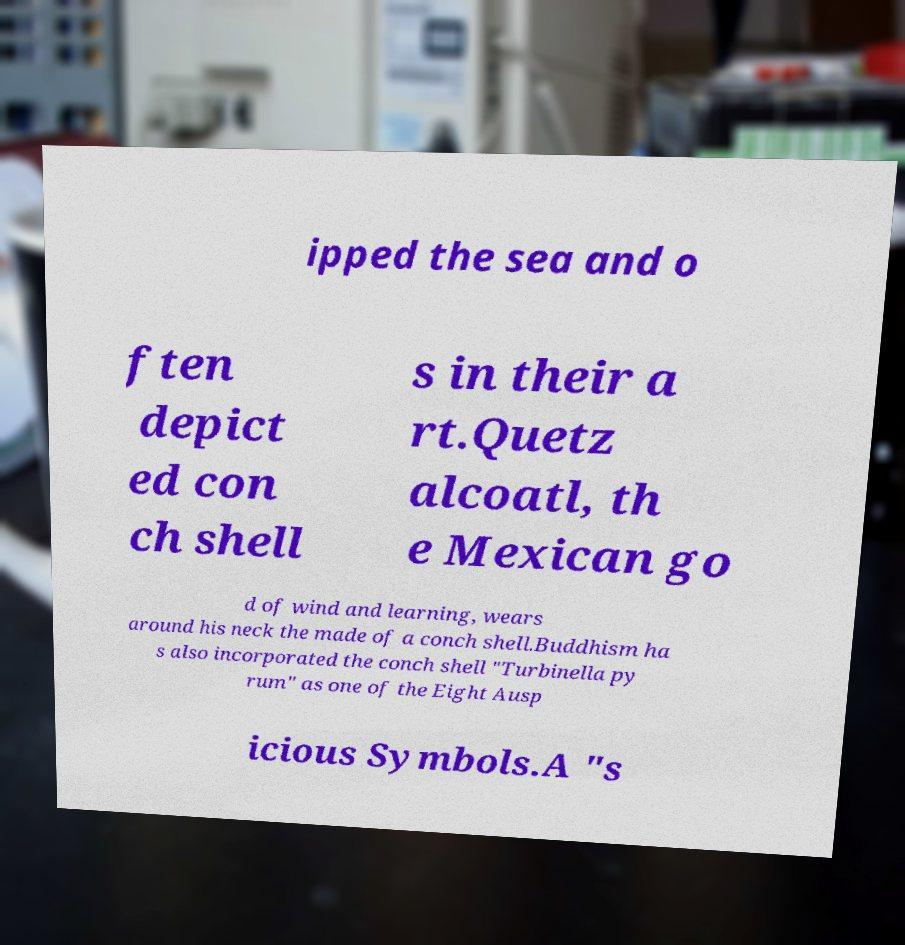Please read and relay the text visible in this image. What does it say? ipped the sea and o ften depict ed con ch shell s in their a rt.Quetz alcoatl, th e Mexican go d of wind and learning, wears around his neck the made of a conch shell.Buddhism ha s also incorporated the conch shell "Turbinella py rum" as one of the Eight Ausp icious Symbols.A "s 